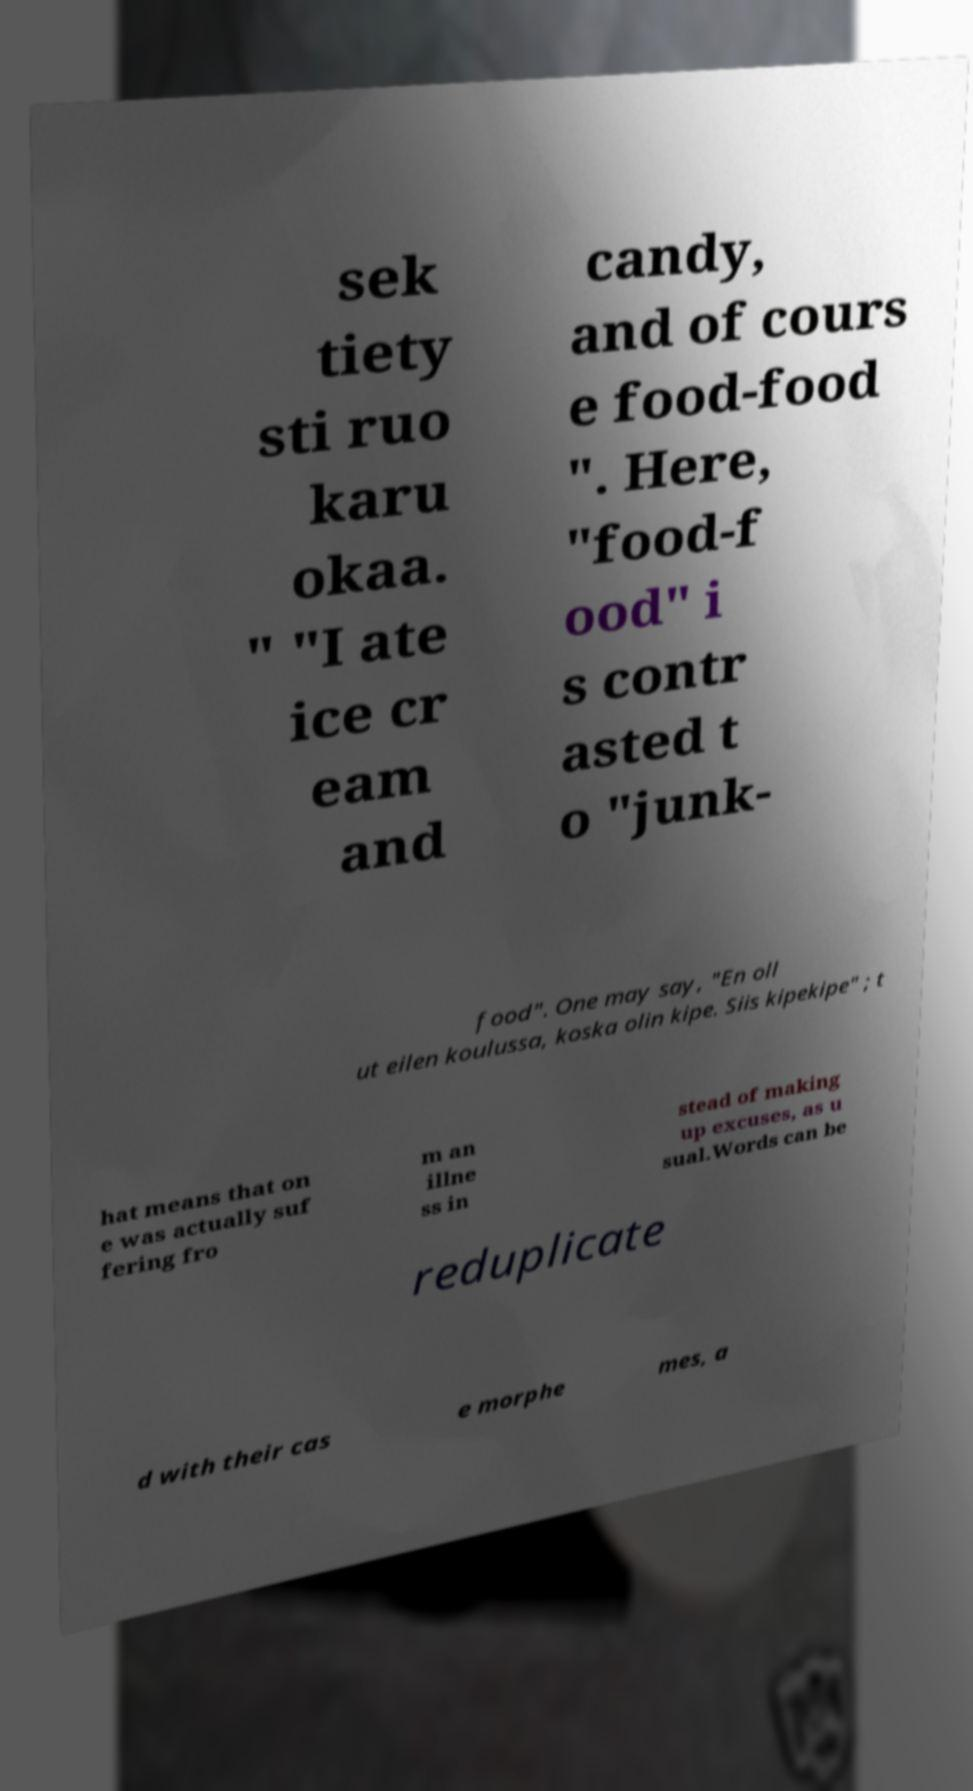For documentation purposes, I need the text within this image transcribed. Could you provide that? sek tiety sti ruo karu okaa. " "I ate ice cr eam and candy, and of cours e food-food ". Here, "food-f ood" i s contr asted t o "junk- food". One may say, "En oll ut eilen koulussa, koska olin kipe. Siis kipekipe" ; t hat means that on e was actually suf fering fro m an illne ss in stead of making up excuses, as u sual.Words can be reduplicate d with their cas e morphe mes, a 